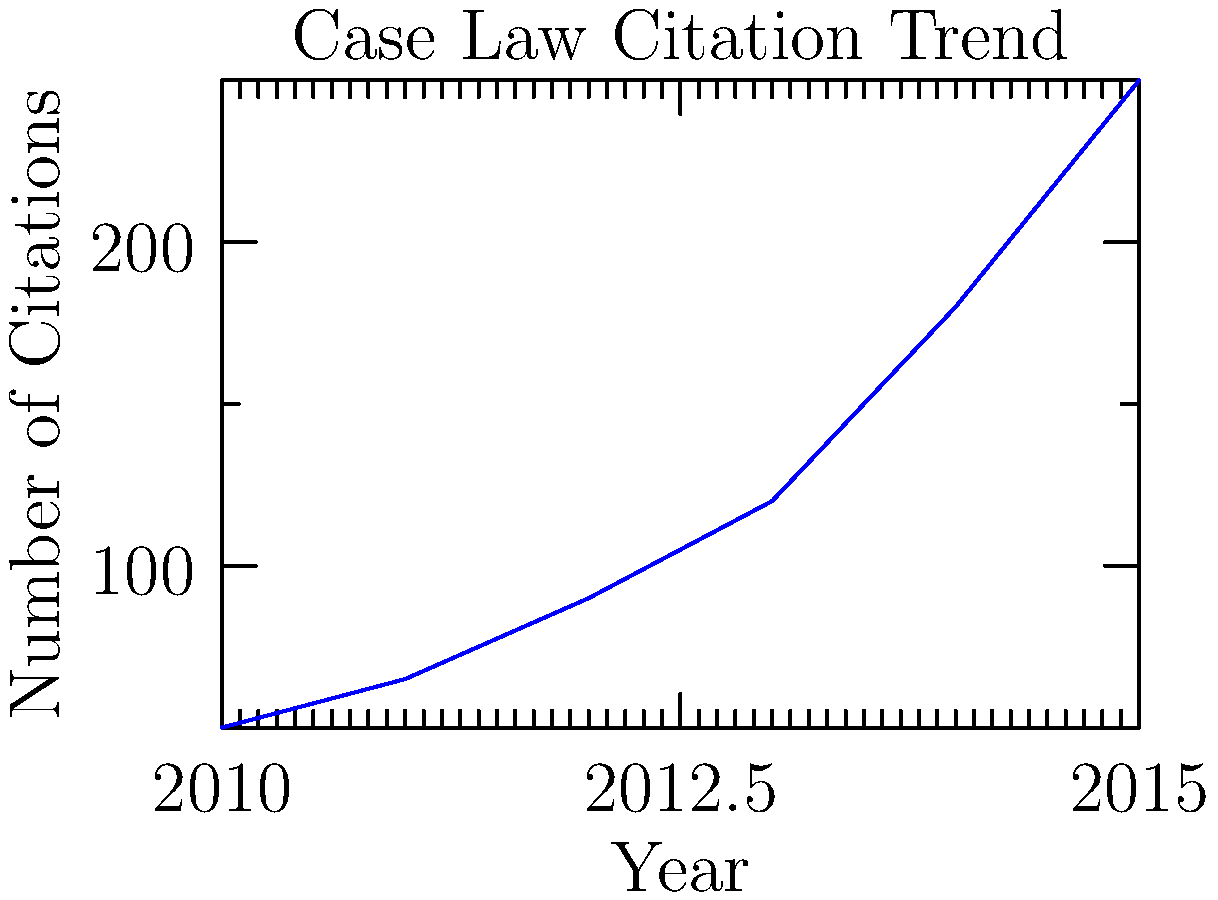A legal researcher is analyzing the trend of citations for a landmark case. The line graph shows the number of citations over a 6-year period. If the trend continues at the same rate of increase, approximately how many citations would be expected in 2017? To solve this problem, we need to follow these steps:

1. Analyze the trend in the graph:
   The line shows an increasing trend, with the rate of increase growing each year.

2. Calculate the year-over-year increase:
   2010 to 2011: 65 - 50 = 15
   2011 to 2012: 90 - 65 = 25
   2012 to 2013: 120 - 90 = 30
   2013 to 2014: 180 - 120 = 60
   2014 to 2015: 250 - 180 = 70

3. Observe the pattern in the increases:
   The increase is growing by about 10 each year (15, 25, 30, 60, 70).

4. Estimate the increases for 2016 and 2017:
   2015 to 2016: Approximately 80 (70 + 10)
   2016 to 2017: Approximately 90 (80 + 10)

5. Calculate the estimated citations for 2016 and 2017:
   2016: 250 + 80 = 330
   2017: 330 + 90 = 420

Therefore, if the trend continues at the same increasing rate, we would expect approximately 420 citations in 2017.
Answer: Approximately 420 citations 